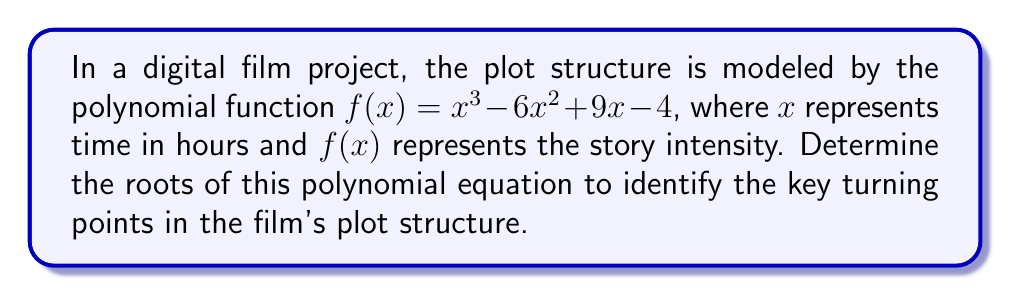Provide a solution to this math problem. To find the roots of the polynomial equation, we need to solve $f(x) = 0$:

1) Set up the equation:
   $x^3 - 6x^2 + 9x - 4 = 0$

2) This is a cubic equation. We can try to factor it:
   $(x - 1)(x^2 - 5x + 4) = 0$

3) From this factored form, we can see that $x = 1$ is one root.

4) For the quadratic factor $x^2 - 5x + 4 = 0$, we can use the quadratic formula:
   $x = \frac{-b \pm \sqrt{b^2 - 4ac}}{2a}$

   Where $a = 1$, $b = -5$, and $c = 4$

5) Substituting into the quadratic formula:
   $x = \frac{5 \pm \sqrt{25 - 16}}{2} = \frac{5 \pm 3}{2}$

6) This gives us two more roots:
   $x = \frac{5 + 3}{2} = 4$ and $x = \frac{5 - 3}{2} = 1$

Therefore, the roots of the polynomial equation are $x = 1$ (twice) and $x = 4$.

These roots represent the key turning points in the film's plot structure, occurring at 1 hour (a double root, suggesting a significant moment) and 4 hours into the film.
Answer: $x = 1$ (double root) and $x = 4$ 